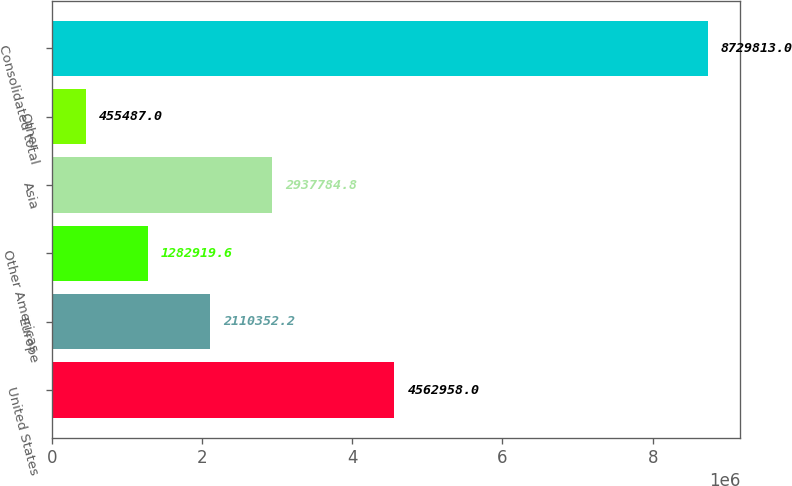Convert chart. <chart><loc_0><loc_0><loc_500><loc_500><bar_chart><fcel>United States<fcel>Europe<fcel>Other Americas<fcel>Asia<fcel>Other<fcel>Consolidated total<nl><fcel>4.56296e+06<fcel>2.11035e+06<fcel>1.28292e+06<fcel>2.93778e+06<fcel>455487<fcel>8.72981e+06<nl></chart> 